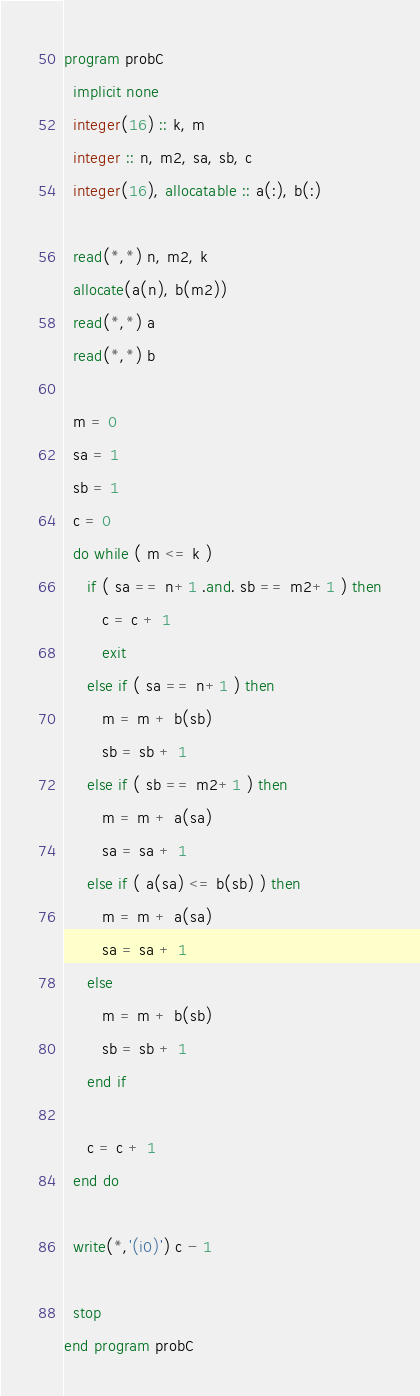<code> <loc_0><loc_0><loc_500><loc_500><_FORTRAN_>program probC
  implicit none
  integer(16) :: k, m
  integer :: n, m2, sa, sb, c
  integer(16), allocatable :: a(:), b(:)

  read(*,*) n, m2, k
  allocate(a(n), b(m2))
  read(*,*) a
  read(*,*) b

  m = 0
  sa = 1
  sb = 1
  c = 0
  do while ( m <= k )
     if ( sa == n+1 .and. sb == m2+1 ) then
        c = c + 1
        exit
     else if ( sa == n+1 ) then
        m = m + b(sb)
        sb = sb + 1
     else if ( sb == m2+1 ) then
        m = m + a(sa)
        sa = sa + 1
     else if ( a(sa) <= b(sb) ) then
        m = m + a(sa)
        sa = sa + 1
     else
        m = m + b(sb)
        sb = sb + 1
     end if
     
     c = c + 1
  end do
  
  write(*,'(i0)') c - 1

  stop
end program probC

</code> 